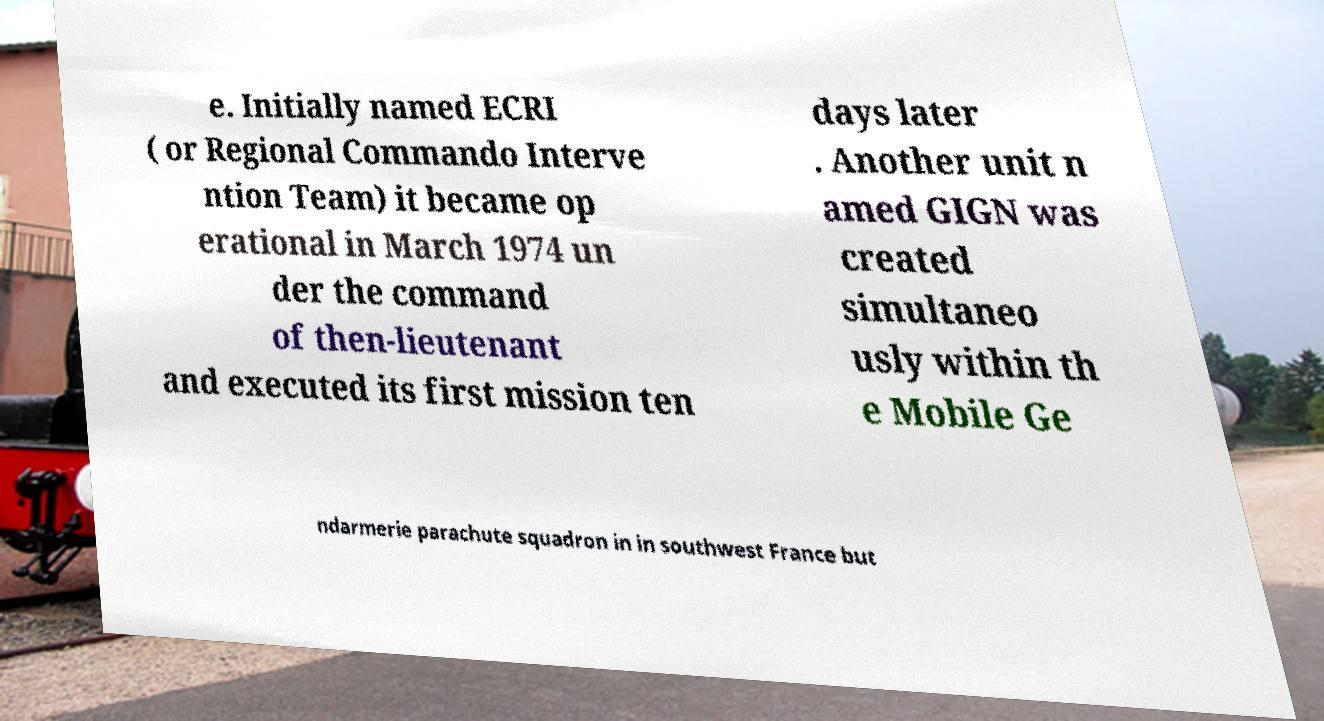Can you read and provide the text displayed in the image?This photo seems to have some interesting text. Can you extract and type it out for me? e. Initially named ECRI ( or Regional Commando Interve ntion Team) it became op erational in March 1974 un der the command of then-lieutenant and executed its first mission ten days later . Another unit n amed GIGN was created simultaneo usly within th e Mobile Ge ndarmerie parachute squadron in in southwest France but 